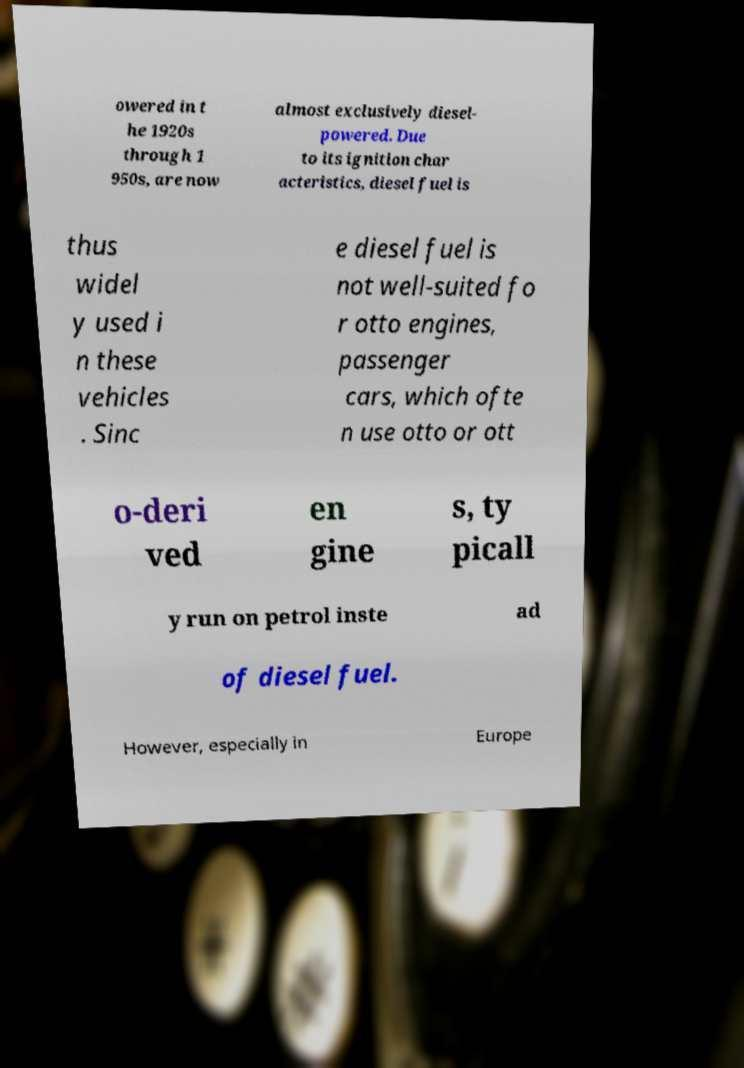What messages or text are displayed in this image? I need them in a readable, typed format. owered in t he 1920s through 1 950s, are now almost exclusively diesel- powered. Due to its ignition char acteristics, diesel fuel is thus widel y used i n these vehicles . Sinc e diesel fuel is not well-suited fo r otto engines, passenger cars, which ofte n use otto or ott o-deri ved en gine s, ty picall y run on petrol inste ad of diesel fuel. However, especially in Europe 